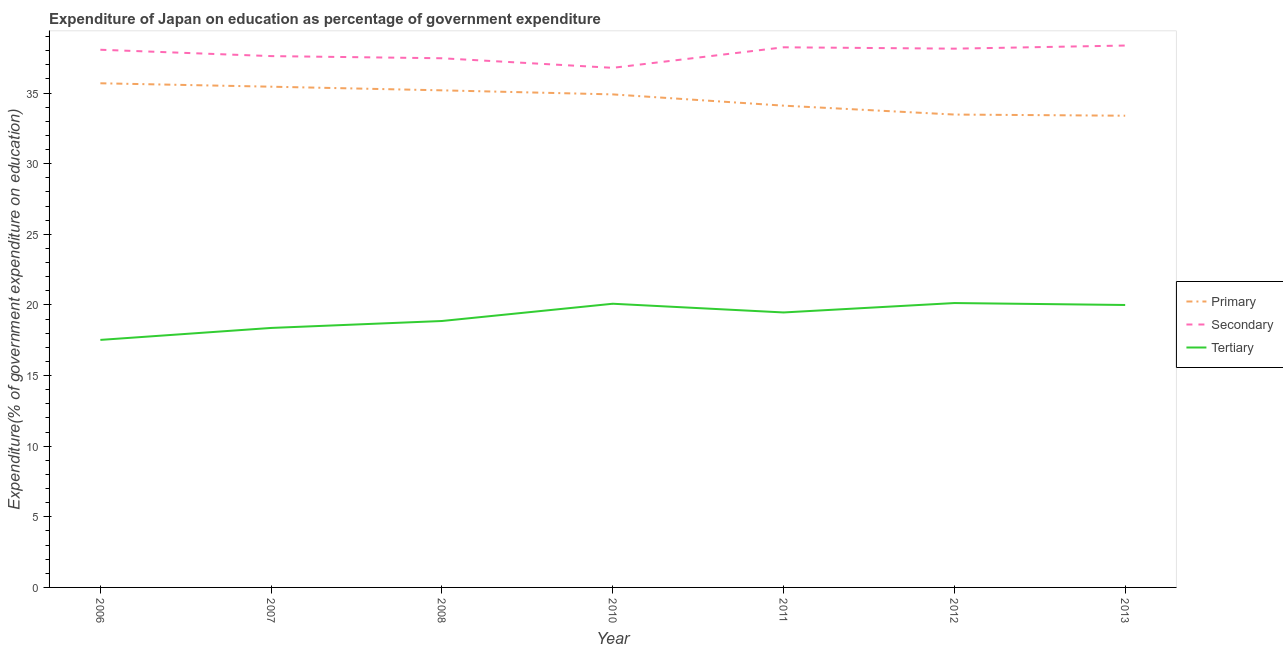How many different coloured lines are there?
Your answer should be compact. 3. Is the number of lines equal to the number of legend labels?
Give a very brief answer. Yes. What is the expenditure on secondary education in 2007?
Provide a short and direct response. 37.62. Across all years, what is the maximum expenditure on tertiary education?
Offer a terse response. 20.14. Across all years, what is the minimum expenditure on tertiary education?
Offer a very short reply. 17.53. In which year was the expenditure on primary education minimum?
Provide a short and direct response. 2013. What is the total expenditure on tertiary education in the graph?
Your answer should be very brief. 134.45. What is the difference between the expenditure on primary education in 2012 and that in 2013?
Provide a succinct answer. 0.08. What is the difference between the expenditure on tertiary education in 2010 and the expenditure on secondary education in 2011?
Your answer should be compact. -18.16. What is the average expenditure on primary education per year?
Provide a succinct answer. 34.61. In the year 2006, what is the difference between the expenditure on primary education and expenditure on secondary education?
Offer a terse response. -2.37. In how many years, is the expenditure on tertiary education greater than 31 %?
Your answer should be compact. 0. What is the ratio of the expenditure on tertiary education in 2008 to that in 2013?
Keep it short and to the point. 0.94. Is the expenditure on secondary education in 2007 less than that in 2013?
Provide a short and direct response. Yes. What is the difference between the highest and the second highest expenditure on secondary education?
Provide a short and direct response. 0.12. What is the difference between the highest and the lowest expenditure on secondary education?
Your answer should be compact. 1.58. In how many years, is the expenditure on tertiary education greater than the average expenditure on tertiary education taken over all years?
Make the answer very short. 4. Is the sum of the expenditure on primary education in 2007 and 2010 greater than the maximum expenditure on tertiary education across all years?
Your answer should be very brief. Yes. Does the expenditure on tertiary education monotonically increase over the years?
Ensure brevity in your answer.  No. Is the expenditure on primary education strictly greater than the expenditure on secondary education over the years?
Offer a terse response. No. Is the expenditure on tertiary education strictly less than the expenditure on secondary education over the years?
Your answer should be compact. Yes. How many years are there in the graph?
Provide a succinct answer. 7. What is the difference between two consecutive major ticks on the Y-axis?
Your response must be concise. 5. Does the graph contain grids?
Offer a terse response. No. Where does the legend appear in the graph?
Ensure brevity in your answer.  Center right. How many legend labels are there?
Make the answer very short. 3. What is the title of the graph?
Offer a terse response. Expenditure of Japan on education as percentage of government expenditure. Does "Taxes" appear as one of the legend labels in the graph?
Give a very brief answer. No. What is the label or title of the X-axis?
Keep it short and to the point. Year. What is the label or title of the Y-axis?
Ensure brevity in your answer.  Expenditure(% of government expenditure on education). What is the Expenditure(% of government expenditure on education) of Primary in 2006?
Provide a succinct answer. 35.7. What is the Expenditure(% of government expenditure on education) of Secondary in 2006?
Give a very brief answer. 38.07. What is the Expenditure(% of government expenditure on education) of Tertiary in 2006?
Offer a terse response. 17.53. What is the Expenditure(% of government expenditure on education) of Primary in 2007?
Offer a terse response. 35.45. What is the Expenditure(% of government expenditure on education) in Secondary in 2007?
Give a very brief answer. 37.62. What is the Expenditure(% of government expenditure on education) in Tertiary in 2007?
Ensure brevity in your answer.  18.37. What is the Expenditure(% of government expenditure on education) in Primary in 2008?
Make the answer very short. 35.2. What is the Expenditure(% of government expenditure on education) of Secondary in 2008?
Provide a succinct answer. 37.47. What is the Expenditure(% of government expenditure on education) in Tertiary in 2008?
Offer a very short reply. 18.86. What is the Expenditure(% of government expenditure on education) of Primary in 2010?
Keep it short and to the point. 34.91. What is the Expenditure(% of government expenditure on education) of Secondary in 2010?
Your answer should be compact. 36.79. What is the Expenditure(% of government expenditure on education) in Tertiary in 2010?
Offer a very short reply. 20.09. What is the Expenditure(% of government expenditure on education) of Primary in 2011?
Make the answer very short. 34.11. What is the Expenditure(% of government expenditure on education) in Secondary in 2011?
Give a very brief answer. 38.24. What is the Expenditure(% of government expenditure on education) of Tertiary in 2011?
Your answer should be very brief. 19.47. What is the Expenditure(% of government expenditure on education) of Primary in 2012?
Your response must be concise. 33.48. What is the Expenditure(% of government expenditure on education) of Secondary in 2012?
Ensure brevity in your answer.  38.15. What is the Expenditure(% of government expenditure on education) in Tertiary in 2012?
Make the answer very short. 20.14. What is the Expenditure(% of government expenditure on education) in Primary in 2013?
Your response must be concise. 33.4. What is the Expenditure(% of government expenditure on education) of Secondary in 2013?
Offer a terse response. 38.37. What is the Expenditure(% of government expenditure on education) in Tertiary in 2013?
Give a very brief answer. 20. Across all years, what is the maximum Expenditure(% of government expenditure on education) of Primary?
Keep it short and to the point. 35.7. Across all years, what is the maximum Expenditure(% of government expenditure on education) in Secondary?
Make the answer very short. 38.37. Across all years, what is the maximum Expenditure(% of government expenditure on education) of Tertiary?
Provide a succinct answer. 20.14. Across all years, what is the minimum Expenditure(% of government expenditure on education) in Primary?
Keep it short and to the point. 33.4. Across all years, what is the minimum Expenditure(% of government expenditure on education) of Secondary?
Offer a very short reply. 36.79. Across all years, what is the minimum Expenditure(% of government expenditure on education) in Tertiary?
Give a very brief answer. 17.53. What is the total Expenditure(% of government expenditure on education) of Primary in the graph?
Your answer should be compact. 242.25. What is the total Expenditure(% of government expenditure on education) of Secondary in the graph?
Provide a succinct answer. 264.7. What is the total Expenditure(% of government expenditure on education) in Tertiary in the graph?
Offer a terse response. 134.45. What is the difference between the Expenditure(% of government expenditure on education) in Primary in 2006 and that in 2007?
Your answer should be compact. 0.24. What is the difference between the Expenditure(% of government expenditure on education) in Secondary in 2006 and that in 2007?
Offer a terse response. 0.45. What is the difference between the Expenditure(% of government expenditure on education) of Tertiary in 2006 and that in 2007?
Your answer should be compact. -0.85. What is the difference between the Expenditure(% of government expenditure on education) in Primary in 2006 and that in 2008?
Provide a short and direct response. 0.5. What is the difference between the Expenditure(% of government expenditure on education) in Secondary in 2006 and that in 2008?
Your answer should be compact. 0.6. What is the difference between the Expenditure(% of government expenditure on education) in Tertiary in 2006 and that in 2008?
Offer a very short reply. -1.34. What is the difference between the Expenditure(% of government expenditure on education) in Primary in 2006 and that in 2010?
Make the answer very short. 0.79. What is the difference between the Expenditure(% of government expenditure on education) in Secondary in 2006 and that in 2010?
Keep it short and to the point. 1.28. What is the difference between the Expenditure(% of government expenditure on education) in Tertiary in 2006 and that in 2010?
Ensure brevity in your answer.  -2.56. What is the difference between the Expenditure(% of government expenditure on education) in Primary in 2006 and that in 2011?
Provide a succinct answer. 1.58. What is the difference between the Expenditure(% of government expenditure on education) in Secondary in 2006 and that in 2011?
Your answer should be compact. -0.17. What is the difference between the Expenditure(% of government expenditure on education) in Tertiary in 2006 and that in 2011?
Your response must be concise. -1.94. What is the difference between the Expenditure(% of government expenditure on education) of Primary in 2006 and that in 2012?
Your response must be concise. 2.21. What is the difference between the Expenditure(% of government expenditure on education) in Secondary in 2006 and that in 2012?
Your answer should be compact. -0.08. What is the difference between the Expenditure(% of government expenditure on education) of Tertiary in 2006 and that in 2012?
Offer a terse response. -2.61. What is the difference between the Expenditure(% of government expenditure on education) in Primary in 2006 and that in 2013?
Offer a very short reply. 2.3. What is the difference between the Expenditure(% of government expenditure on education) in Secondary in 2006 and that in 2013?
Give a very brief answer. -0.3. What is the difference between the Expenditure(% of government expenditure on education) in Tertiary in 2006 and that in 2013?
Offer a terse response. -2.47. What is the difference between the Expenditure(% of government expenditure on education) in Primary in 2007 and that in 2008?
Make the answer very short. 0.26. What is the difference between the Expenditure(% of government expenditure on education) of Secondary in 2007 and that in 2008?
Provide a succinct answer. 0.15. What is the difference between the Expenditure(% of government expenditure on education) of Tertiary in 2007 and that in 2008?
Make the answer very short. -0.49. What is the difference between the Expenditure(% of government expenditure on education) of Primary in 2007 and that in 2010?
Offer a terse response. 0.54. What is the difference between the Expenditure(% of government expenditure on education) of Secondary in 2007 and that in 2010?
Ensure brevity in your answer.  0.83. What is the difference between the Expenditure(% of government expenditure on education) of Tertiary in 2007 and that in 2010?
Provide a succinct answer. -1.71. What is the difference between the Expenditure(% of government expenditure on education) of Primary in 2007 and that in 2011?
Your answer should be compact. 1.34. What is the difference between the Expenditure(% of government expenditure on education) of Secondary in 2007 and that in 2011?
Make the answer very short. -0.62. What is the difference between the Expenditure(% of government expenditure on education) of Tertiary in 2007 and that in 2011?
Keep it short and to the point. -1.1. What is the difference between the Expenditure(% of government expenditure on education) in Primary in 2007 and that in 2012?
Offer a terse response. 1.97. What is the difference between the Expenditure(% of government expenditure on education) in Secondary in 2007 and that in 2012?
Give a very brief answer. -0.53. What is the difference between the Expenditure(% of government expenditure on education) in Tertiary in 2007 and that in 2012?
Provide a short and direct response. -1.76. What is the difference between the Expenditure(% of government expenditure on education) of Primary in 2007 and that in 2013?
Keep it short and to the point. 2.05. What is the difference between the Expenditure(% of government expenditure on education) of Secondary in 2007 and that in 2013?
Give a very brief answer. -0.75. What is the difference between the Expenditure(% of government expenditure on education) of Tertiary in 2007 and that in 2013?
Provide a succinct answer. -1.62. What is the difference between the Expenditure(% of government expenditure on education) of Primary in 2008 and that in 2010?
Make the answer very short. 0.29. What is the difference between the Expenditure(% of government expenditure on education) in Secondary in 2008 and that in 2010?
Make the answer very short. 0.68. What is the difference between the Expenditure(% of government expenditure on education) of Tertiary in 2008 and that in 2010?
Provide a succinct answer. -1.22. What is the difference between the Expenditure(% of government expenditure on education) of Primary in 2008 and that in 2011?
Offer a very short reply. 1.08. What is the difference between the Expenditure(% of government expenditure on education) of Secondary in 2008 and that in 2011?
Ensure brevity in your answer.  -0.78. What is the difference between the Expenditure(% of government expenditure on education) in Tertiary in 2008 and that in 2011?
Ensure brevity in your answer.  -0.6. What is the difference between the Expenditure(% of government expenditure on education) of Primary in 2008 and that in 2012?
Ensure brevity in your answer.  1.71. What is the difference between the Expenditure(% of government expenditure on education) of Secondary in 2008 and that in 2012?
Ensure brevity in your answer.  -0.68. What is the difference between the Expenditure(% of government expenditure on education) in Tertiary in 2008 and that in 2012?
Offer a terse response. -1.27. What is the difference between the Expenditure(% of government expenditure on education) in Primary in 2008 and that in 2013?
Provide a short and direct response. 1.8. What is the difference between the Expenditure(% of government expenditure on education) of Secondary in 2008 and that in 2013?
Give a very brief answer. -0.9. What is the difference between the Expenditure(% of government expenditure on education) of Tertiary in 2008 and that in 2013?
Offer a very short reply. -1.13. What is the difference between the Expenditure(% of government expenditure on education) of Primary in 2010 and that in 2011?
Offer a very short reply. 0.8. What is the difference between the Expenditure(% of government expenditure on education) of Secondary in 2010 and that in 2011?
Provide a short and direct response. -1.45. What is the difference between the Expenditure(% of government expenditure on education) of Tertiary in 2010 and that in 2011?
Keep it short and to the point. 0.62. What is the difference between the Expenditure(% of government expenditure on education) in Primary in 2010 and that in 2012?
Keep it short and to the point. 1.43. What is the difference between the Expenditure(% of government expenditure on education) in Secondary in 2010 and that in 2012?
Keep it short and to the point. -1.36. What is the difference between the Expenditure(% of government expenditure on education) in Tertiary in 2010 and that in 2012?
Offer a very short reply. -0.05. What is the difference between the Expenditure(% of government expenditure on education) of Primary in 2010 and that in 2013?
Make the answer very short. 1.51. What is the difference between the Expenditure(% of government expenditure on education) in Secondary in 2010 and that in 2013?
Your answer should be very brief. -1.58. What is the difference between the Expenditure(% of government expenditure on education) in Tertiary in 2010 and that in 2013?
Provide a succinct answer. 0.09. What is the difference between the Expenditure(% of government expenditure on education) of Primary in 2011 and that in 2012?
Provide a short and direct response. 0.63. What is the difference between the Expenditure(% of government expenditure on education) of Secondary in 2011 and that in 2012?
Your answer should be compact. 0.1. What is the difference between the Expenditure(% of government expenditure on education) in Tertiary in 2011 and that in 2012?
Make the answer very short. -0.67. What is the difference between the Expenditure(% of government expenditure on education) of Primary in 2011 and that in 2013?
Your answer should be compact. 0.71. What is the difference between the Expenditure(% of government expenditure on education) of Secondary in 2011 and that in 2013?
Your answer should be compact. -0.12. What is the difference between the Expenditure(% of government expenditure on education) in Tertiary in 2011 and that in 2013?
Your response must be concise. -0.53. What is the difference between the Expenditure(% of government expenditure on education) in Primary in 2012 and that in 2013?
Provide a succinct answer. 0.08. What is the difference between the Expenditure(% of government expenditure on education) in Secondary in 2012 and that in 2013?
Provide a short and direct response. -0.22. What is the difference between the Expenditure(% of government expenditure on education) in Tertiary in 2012 and that in 2013?
Give a very brief answer. 0.14. What is the difference between the Expenditure(% of government expenditure on education) in Primary in 2006 and the Expenditure(% of government expenditure on education) in Secondary in 2007?
Offer a very short reply. -1.92. What is the difference between the Expenditure(% of government expenditure on education) in Primary in 2006 and the Expenditure(% of government expenditure on education) in Tertiary in 2007?
Offer a terse response. 17.32. What is the difference between the Expenditure(% of government expenditure on education) in Secondary in 2006 and the Expenditure(% of government expenditure on education) in Tertiary in 2007?
Your response must be concise. 19.7. What is the difference between the Expenditure(% of government expenditure on education) in Primary in 2006 and the Expenditure(% of government expenditure on education) in Secondary in 2008?
Your response must be concise. -1.77. What is the difference between the Expenditure(% of government expenditure on education) in Primary in 2006 and the Expenditure(% of government expenditure on education) in Tertiary in 2008?
Your answer should be compact. 16.83. What is the difference between the Expenditure(% of government expenditure on education) of Secondary in 2006 and the Expenditure(% of government expenditure on education) of Tertiary in 2008?
Provide a succinct answer. 19.21. What is the difference between the Expenditure(% of government expenditure on education) of Primary in 2006 and the Expenditure(% of government expenditure on education) of Secondary in 2010?
Provide a short and direct response. -1.09. What is the difference between the Expenditure(% of government expenditure on education) in Primary in 2006 and the Expenditure(% of government expenditure on education) in Tertiary in 2010?
Your response must be concise. 15.61. What is the difference between the Expenditure(% of government expenditure on education) in Secondary in 2006 and the Expenditure(% of government expenditure on education) in Tertiary in 2010?
Offer a terse response. 17.98. What is the difference between the Expenditure(% of government expenditure on education) of Primary in 2006 and the Expenditure(% of government expenditure on education) of Secondary in 2011?
Your answer should be very brief. -2.55. What is the difference between the Expenditure(% of government expenditure on education) in Primary in 2006 and the Expenditure(% of government expenditure on education) in Tertiary in 2011?
Provide a short and direct response. 16.23. What is the difference between the Expenditure(% of government expenditure on education) of Secondary in 2006 and the Expenditure(% of government expenditure on education) of Tertiary in 2011?
Your answer should be very brief. 18.6. What is the difference between the Expenditure(% of government expenditure on education) in Primary in 2006 and the Expenditure(% of government expenditure on education) in Secondary in 2012?
Give a very brief answer. -2.45. What is the difference between the Expenditure(% of government expenditure on education) in Primary in 2006 and the Expenditure(% of government expenditure on education) in Tertiary in 2012?
Provide a succinct answer. 15.56. What is the difference between the Expenditure(% of government expenditure on education) of Secondary in 2006 and the Expenditure(% of government expenditure on education) of Tertiary in 2012?
Make the answer very short. 17.93. What is the difference between the Expenditure(% of government expenditure on education) of Primary in 2006 and the Expenditure(% of government expenditure on education) of Secondary in 2013?
Make the answer very short. -2.67. What is the difference between the Expenditure(% of government expenditure on education) of Primary in 2006 and the Expenditure(% of government expenditure on education) of Tertiary in 2013?
Ensure brevity in your answer.  15.7. What is the difference between the Expenditure(% of government expenditure on education) in Secondary in 2006 and the Expenditure(% of government expenditure on education) in Tertiary in 2013?
Keep it short and to the point. 18.07. What is the difference between the Expenditure(% of government expenditure on education) of Primary in 2007 and the Expenditure(% of government expenditure on education) of Secondary in 2008?
Keep it short and to the point. -2.01. What is the difference between the Expenditure(% of government expenditure on education) in Primary in 2007 and the Expenditure(% of government expenditure on education) in Tertiary in 2008?
Provide a short and direct response. 16.59. What is the difference between the Expenditure(% of government expenditure on education) in Secondary in 2007 and the Expenditure(% of government expenditure on education) in Tertiary in 2008?
Your answer should be compact. 18.76. What is the difference between the Expenditure(% of government expenditure on education) of Primary in 2007 and the Expenditure(% of government expenditure on education) of Secondary in 2010?
Your response must be concise. -1.34. What is the difference between the Expenditure(% of government expenditure on education) in Primary in 2007 and the Expenditure(% of government expenditure on education) in Tertiary in 2010?
Your answer should be compact. 15.37. What is the difference between the Expenditure(% of government expenditure on education) of Secondary in 2007 and the Expenditure(% of government expenditure on education) of Tertiary in 2010?
Offer a terse response. 17.53. What is the difference between the Expenditure(% of government expenditure on education) of Primary in 2007 and the Expenditure(% of government expenditure on education) of Secondary in 2011?
Keep it short and to the point. -2.79. What is the difference between the Expenditure(% of government expenditure on education) in Primary in 2007 and the Expenditure(% of government expenditure on education) in Tertiary in 2011?
Your answer should be very brief. 15.98. What is the difference between the Expenditure(% of government expenditure on education) in Secondary in 2007 and the Expenditure(% of government expenditure on education) in Tertiary in 2011?
Your answer should be compact. 18.15. What is the difference between the Expenditure(% of government expenditure on education) of Primary in 2007 and the Expenditure(% of government expenditure on education) of Secondary in 2012?
Your answer should be very brief. -2.69. What is the difference between the Expenditure(% of government expenditure on education) of Primary in 2007 and the Expenditure(% of government expenditure on education) of Tertiary in 2012?
Your answer should be compact. 15.32. What is the difference between the Expenditure(% of government expenditure on education) in Secondary in 2007 and the Expenditure(% of government expenditure on education) in Tertiary in 2012?
Keep it short and to the point. 17.48. What is the difference between the Expenditure(% of government expenditure on education) of Primary in 2007 and the Expenditure(% of government expenditure on education) of Secondary in 2013?
Offer a very short reply. -2.91. What is the difference between the Expenditure(% of government expenditure on education) of Primary in 2007 and the Expenditure(% of government expenditure on education) of Tertiary in 2013?
Offer a terse response. 15.46. What is the difference between the Expenditure(% of government expenditure on education) in Secondary in 2007 and the Expenditure(% of government expenditure on education) in Tertiary in 2013?
Your response must be concise. 17.62. What is the difference between the Expenditure(% of government expenditure on education) of Primary in 2008 and the Expenditure(% of government expenditure on education) of Secondary in 2010?
Your answer should be very brief. -1.59. What is the difference between the Expenditure(% of government expenditure on education) in Primary in 2008 and the Expenditure(% of government expenditure on education) in Tertiary in 2010?
Provide a short and direct response. 15.11. What is the difference between the Expenditure(% of government expenditure on education) of Secondary in 2008 and the Expenditure(% of government expenditure on education) of Tertiary in 2010?
Keep it short and to the point. 17.38. What is the difference between the Expenditure(% of government expenditure on education) of Primary in 2008 and the Expenditure(% of government expenditure on education) of Secondary in 2011?
Ensure brevity in your answer.  -3.05. What is the difference between the Expenditure(% of government expenditure on education) of Primary in 2008 and the Expenditure(% of government expenditure on education) of Tertiary in 2011?
Offer a terse response. 15.73. What is the difference between the Expenditure(% of government expenditure on education) of Secondary in 2008 and the Expenditure(% of government expenditure on education) of Tertiary in 2011?
Give a very brief answer. 18. What is the difference between the Expenditure(% of government expenditure on education) of Primary in 2008 and the Expenditure(% of government expenditure on education) of Secondary in 2012?
Offer a very short reply. -2.95. What is the difference between the Expenditure(% of government expenditure on education) in Primary in 2008 and the Expenditure(% of government expenditure on education) in Tertiary in 2012?
Offer a terse response. 15.06. What is the difference between the Expenditure(% of government expenditure on education) of Secondary in 2008 and the Expenditure(% of government expenditure on education) of Tertiary in 2012?
Keep it short and to the point. 17.33. What is the difference between the Expenditure(% of government expenditure on education) in Primary in 2008 and the Expenditure(% of government expenditure on education) in Secondary in 2013?
Ensure brevity in your answer.  -3.17. What is the difference between the Expenditure(% of government expenditure on education) of Primary in 2008 and the Expenditure(% of government expenditure on education) of Tertiary in 2013?
Your answer should be very brief. 15.2. What is the difference between the Expenditure(% of government expenditure on education) in Secondary in 2008 and the Expenditure(% of government expenditure on education) in Tertiary in 2013?
Give a very brief answer. 17.47. What is the difference between the Expenditure(% of government expenditure on education) of Primary in 2010 and the Expenditure(% of government expenditure on education) of Secondary in 2011?
Your answer should be compact. -3.33. What is the difference between the Expenditure(% of government expenditure on education) of Primary in 2010 and the Expenditure(% of government expenditure on education) of Tertiary in 2011?
Your answer should be very brief. 15.44. What is the difference between the Expenditure(% of government expenditure on education) of Secondary in 2010 and the Expenditure(% of government expenditure on education) of Tertiary in 2011?
Your answer should be compact. 17.32. What is the difference between the Expenditure(% of government expenditure on education) of Primary in 2010 and the Expenditure(% of government expenditure on education) of Secondary in 2012?
Offer a terse response. -3.24. What is the difference between the Expenditure(% of government expenditure on education) in Primary in 2010 and the Expenditure(% of government expenditure on education) in Tertiary in 2012?
Your answer should be very brief. 14.77. What is the difference between the Expenditure(% of government expenditure on education) of Secondary in 2010 and the Expenditure(% of government expenditure on education) of Tertiary in 2012?
Your answer should be compact. 16.65. What is the difference between the Expenditure(% of government expenditure on education) of Primary in 2010 and the Expenditure(% of government expenditure on education) of Secondary in 2013?
Provide a succinct answer. -3.46. What is the difference between the Expenditure(% of government expenditure on education) of Primary in 2010 and the Expenditure(% of government expenditure on education) of Tertiary in 2013?
Make the answer very short. 14.91. What is the difference between the Expenditure(% of government expenditure on education) in Secondary in 2010 and the Expenditure(% of government expenditure on education) in Tertiary in 2013?
Your answer should be very brief. 16.79. What is the difference between the Expenditure(% of government expenditure on education) in Primary in 2011 and the Expenditure(% of government expenditure on education) in Secondary in 2012?
Offer a very short reply. -4.04. What is the difference between the Expenditure(% of government expenditure on education) of Primary in 2011 and the Expenditure(% of government expenditure on education) of Tertiary in 2012?
Your answer should be very brief. 13.98. What is the difference between the Expenditure(% of government expenditure on education) of Secondary in 2011 and the Expenditure(% of government expenditure on education) of Tertiary in 2012?
Your answer should be compact. 18.11. What is the difference between the Expenditure(% of government expenditure on education) of Primary in 2011 and the Expenditure(% of government expenditure on education) of Secondary in 2013?
Provide a succinct answer. -4.26. What is the difference between the Expenditure(% of government expenditure on education) of Primary in 2011 and the Expenditure(% of government expenditure on education) of Tertiary in 2013?
Make the answer very short. 14.11. What is the difference between the Expenditure(% of government expenditure on education) in Secondary in 2011 and the Expenditure(% of government expenditure on education) in Tertiary in 2013?
Provide a short and direct response. 18.25. What is the difference between the Expenditure(% of government expenditure on education) of Primary in 2012 and the Expenditure(% of government expenditure on education) of Secondary in 2013?
Your answer should be very brief. -4.89. What is the difference between the Expenditure(% of government expenditure on education) of Primary in 2012 and the Expenditure(% of government expenditure on education) of Tertiary in 2013?
Provide a succinct answer. 13.48. What is the difference between the Expenditure(% of government expenditure on education) in Secondary in 2012 and the Expenditure(% of government expenditure on education) in Tertiary in 2013?
Provide a short and direct response. 18.15. What is the average Expenditure(% of government expenditure on education) of Primary per year?
Ensure brevity in your answer.  34.61. What is the average Expenditure(% of government expenditure on education) in Secondary per year?
Keep it short and to the point. 37.81. What is the average Expenditure(% of government expenditure on education) in Tertiary per year?
Provide a short and direct response. 19.21. In the year 2006, what is the difference between the Expenditure(% of government expenditure on education) of Primary and Expenditure(% of government expenditure on education) of Secondary?
Your answer should be very brief. -2.37. In the year 2006, what is the difference between the Expenditure(% of government expenditure on education) of Primary and Expenditure(% of government expenditure on education) of Tertiary?
Offer a terse response. 18.17. In the year 2006, what is the difference between the Expenditure(% of government expenditure on education) of Secondary and Expenditure(% of government expenditure on education) of Tertiary?
Keep it short and to the point. 20.54. In the year 2007, what is the difference between the Expenditure(% of government expenditure on education) in Primary and Expenditure(% of government expenditure on education) in Secondary?
Keep it short and to the point. -2.17. In the year 2007, what is the difference between the Expenditure(% of government expenditure on education) in Primary and Expenditure(% of government expenditure on education) in Tertiary?
Your response must be concise. 17.08. In the year 2007, what is the difference between the Expenditure(% of government expenditure on education) of Secondary and Expenditure(% of government expenditure on education) of Tertiary?
Make the answer very short. 19.25. In the year 2008, what is the difference between the Expenditure(% of government expenditure on education) in Primary and Expenditure(% of government expenditure on education) in Secondary?
Provide a succinct answer. -2.27. In the year 2008, what is the difference between the Expenditure(% of government expenditure on education) of Primary and Expenditure(% of government expenditure on education) of Tertiary?
Keep it short and to the point. 16.33. In the year 2008, what is the difference between the Expenditure(% of government expenditure on education) in Secondary and Expenditure(% of government expenditure on education) in Tertiary?
Your response must be concise. 18.6. In the year 2010, what is the difference between the Expenditure(% of government expenditure on education) in Primary and Expenditure(% of government expenditure on education) in Secondary?
Your answer should be compact. -1.88. In the year 2010, what is the difference between the Expenditure(% of government expenditure on education) of Primary and Expenditure(% of government expenditure on education) of Tertiary?
Offer a very short reply. 14.82. In the year 2010, what is the difference between the Expenditure(% of government expenditure on education) of Secondary and Expenditure(% of government expenditure on education) of Tertiary?
Your response must be concise. 16.7. In the year 2011, what is the difference between the Expenditure(% of government expenditure on education) in Primary and Expenditure(% of government expenditure on education) in Secondary?
Offer a very short reply. -4.13. In the year 2011, what is the difference between the Expenditure(% of government expenditure on education) of Primary and Expenditure(% of government expenditure on education) of Tertiary?
Provide a succinct answer. 14.64. In the year 2011, what is the difference between the Expenditure(% of government expenditure on education) in Secondary and Expenditure(% of government expenditure on education) in Tertiary?
Give a very brief answer. 18.77. In the year 2012, what is the difference between the Expenditure(% of government expenditure on education) of Primary and Expenditure(% of government expenditure on education) of Secondary?
Ensure brevity in your answer.  -4.67. In the year 2012, what is the difference between the Expenditure(% of government expenditure on education) in Primary and Expenditure(% of government expenditure on education) in Tertiary?
Give a very brief answer. 13.35. In the year 2012, what is the difference between the Expenditure(% of government expenditure on education) of Secondary and Expenditure(% of government expenditure on education) of Tertiary?
Your response must be concise. 18.01. In the year 2013, what is the difference between the Expenditure(% of government expenditure on education) in Primary and Expenditure(% of government expenditure on education) in Secondary?
Provide a short and direct response. -4.97. In the year 2013, what is the difference between the Expenditure(% of government expenditure on education) in Primary and Expenditure(% of government expenditure on education) in Tertiary?
Give a very brief answer. 13.4. In the year 2013, what is the difference between the Expenditure(% of government expenditure on education) in Secondary and Expenditure(% of government expenditure on education) in Tertiary?
Offer a terse response. 18.37. What is the ratio of the Expenditure(% of government expenditure on education) in Primary in 2006 to that in 2007?
Give a very brief answer. 1.01. What is the ratio of the Expenditure(% of government expenditure on education) in Tertiary in 2006 to that in 2007?
Provide a short and direct response. 0.95. What is the ratio of the Expenditure(% of government expenditure on education) of Primary in 2006 to that in 2008?
Offer a very short reply. 1.01. What is the ratio of the Expenditure(% of government expenditure on education) of Secondary in 2006 to that in 2008?
Provide a succinct answer. 1.02. What is the ratio of the Expenditure(% of government expenditure on education) of Tertiary in 2006 to that in 2008?
Make the answer very short. 0.93. What is the ratio of the Expenditure(% of government expenditure on education) in Primary in 2006 to that in 2010?
Provide a short and direct response. 1.02. What is the ratio of the Expenditure(% of government expenditure on education) of Secondary in 2006 to that in 2010?
Give a very brief answer. 1.03. What is the ratio of the Expenditure(% of government expenditure on education) of Tertiary in 2006 to that in 2010?
Provide a short and direct response. 0.87. What is the ratio of the Expenditure(% of government expenditure on education) in Primary in 2006 to that in 2011?
Offer a very short reply. 1.05. What is the ratio of the Expenditure(% of government expenditure on education) of Tertiary in 2006 to that in 2011?
Your answer should be compact. 0.9. What is the ratio of the Expenditure(% of government expenditure on education) in Primary in 2006 to that in 2012?
Your answer should be compact. 1.07. What is the ratio of the Expenditure(% of government expenditure on education) of Secondary in 2006 to that in 2012?
Offer a terse response. 1. What is the ratio of the Expenditure(% of government expenditure on education) in Tertiary in 2006 to that in 2012?
Provide a succinct answer. 0.87. What is the ratio of the Expenditure(% of government expenditure on education) of Primary in 2006 to that in 2013?
Your answer should be compact. 1.07. What is the ratio of the Expenditure(% of government expenditure on education) in Tertiary in 2006 to that in 2013?
Give a very brief answer. 0.88. What is the ratio of the Expenditure(% of government expenditure on education) of Primary in 2007 to that in 2008?
Ensure brevity in your answer.  1.01. What is the ratio of the Expenditure(% of government expenditure on education) of Tertiary in 2007 to that in 2008?
Your answer should be very brief. 0.97. What is the ratio of the Expenditure(% of government expenditure on education) in Primary in 2007 to that in 2010?
Make the answer very short. 1.02. What is the ratio of the Expenditure(% of government expenditure on education) in Secondary in 2007 to that in 2010?
Your answer should be very brief. 1.02. What is the ratio of the Expenditure(% of government expenditure on education) of Tertiary in 2007 to that in 2010?
Give a very brief answer. 0.91. What is the ratio of the Expenditure(% of government expenditure on education) in Primary in 2007 to that in 2011?
Provide a succinct answer. 1.04. What is the ratio of the Expenditure(% of government expenditure on education) of Secondary in 2007 to that in 2011?
Your answer should be compact. 0.98. What is the ratio of the Expenditure(% of government expenditure on education) of Tertiary in 2007 to that in 2011?
Your answer should be compact. 0.94. What is the ratio of the Expenditure(% of government expenditure on education) of Primary in 2007 to that in 2012?
Provide a succinct answer. 1.06. What is the ratio of the Expenditure(% of government expenditure on education) of Secondary in 2007 to that in 2012?
Keep it short and to the point. 0.99. What is the ratio of the Expenditure(% of government expenditure on education) in Tertiary in 2007 to that in 2012?
Ensure brevity in your answer.  0.91. What is the ratio of the Expenditure(% of government expenditure on education) of Primary in 2007 to that in 2013?
Make the answer very short. 1.06. What is the ratio of the Expenditure(% of government expenditure on education) in Secondary in 2007 to that in 2013?
Keep it short and to the point. 0.98. What is the ratio of the Expenditure(% of government expenditure on education) of Tertiary in 2007 to that in 2013?
Provide a short and direct response. 0.92. What is the ratio of the Expenditure(% of government expenditure on education) of Primary in 2008 to that in 2010?
Your response must be concise. 1.01. What is the ratio of the Expenditure(% of government expenditure on education) in Secondary in 2008 to that in 2010?
Offer a terse response. 1.02. What is the ratio of the Expenditure(% of government expenditure on education) in Tertiary in 2008 to that in 2010?
Your answer should be very brief. 0.94. What is the ratio of the Expenditure(% of government expenditure on education) of Primary in 2008 to that in 2011?
Make the answer very short. 1.03. What is the ratio of the Expenditure(% of government expenditure on education) in Secondary in 2008 to that in 2011?
Your answer should be very brief. 0.98. What is the ratio of the Expenditure(% of government expenditure on education) of Primary in 2008 to that in 2012?
Ensure brevity in your answer.  1.05. What is the ratio of the Expenditure(% of government expenditure on education) of Secondary in 2008 to that in 2012?
Give a very brief answer. 0.98. What is the ratio of the Expenditure(% of government expenditure on education) of Tertiary in 2008 to that in 2012?
Your response must be concise. 0.94. What is the ratio of the Expenditure(% of government expenditure on education) in Primary in 2008 to that in 2013?
Offer a terse response. 1.05. What is the ratio of the Expenditure(% of government expenditure on education) of Secondary in 2008 to that in 2013?
Your answer should be compact. 0.98. What is the ratio of the Expenditure(% of government expenditure on education) of Tertiary in 2008 to that in 2013?
Your answer should be very brief. 0.94. What is the ratio of the Expenditure(% of government expenditure on education) in Primary in 2010 to that in 2011?
Offer a very short reply. 1.02. What is the ratio of the Expenditure(% of government expenditure on education) in Secondary in 2010 to that in 2011?
Your answer should be very brief. 0.96. What is the ratio of the Expenditure(% of government expenditure on education) of Tertiary in 2010 to that in 2011?
Ensure brevity in your answer.  1.03. What is the ratio of the Expenditure(% of government expenditure on education) in Primary in 2010 to that in 2012?
Offer a very short reply. 1.04. What is the ratio of the Expenditure(% of government expenditure on education) in Secondary in 2010 to that in 2012?
Keep it short and to the point. 0.96. What is the ratio of the Expenditure(% of government expenditure on education) of Primary in 2010 to that in 2013?
Offer a very short reply. 1.05. What is the ratio of the Expenditure(% of government expenditure on education) in Secondary in 2010 to that in 2013?
Offer a very short reply. 0.96. What is the ratio of the Expenditure(% of government expenditure on education) in Primary in 2011 to that in 2012?
Provide a succinct answer. 1.02. What is the ratio of the Expenditure(% of government expenditure on education) of Tertiary in 2011 to that in 2012?
Offer a very short reply. 0.97. What is the ratio of the Expenditure(% of government expenditure on education) of Primary in 2011 to that in 2013?
Offer a very short reply. 1.02. What is the ratio of the Expenditure(% of government expenditure on education) of Secondary in 2011 to that in 2013?
Your answer should be very brief. 1. What is the ratio of the Expenditure(% of government expenditure on education) of Tertiary in 2011 to that in 2013?
Your answer should be very brief. 0.97. What is the ratio of the Expenditure(% of government expenditure on education) in Primary in 2012 to that in 2013?
Your answer should be very brief. 1. What is the difference between the highest and the second highest Expenditure(% of government expenditure on education) of Primary?
Offer a terse response. 0.24. What is the difference between the highest and the second highest Expenditure(% of government expenditure on education) of Secondary?
Provide a short and direct response. 0.12. What is the difference between the highest and the second highest Expenditure(% of government expenditure on education) in Tertiary?
Ensure brevity in your answer.  0.05. What is the difference between the highest and the lowest Expenditure(% of government expenditure on education) in Primary?
Keep it short and to the point. 2.3. What is the difference between the highest and the lowest Expenditure(% of government expenditure on education) of Secondary?
Provide a succinct answer. 1.58. What is the difference between the highest and the lowest Expenditure(% of government expenditure on education) of Tertiary?
Offer a terse response. 2.61. 